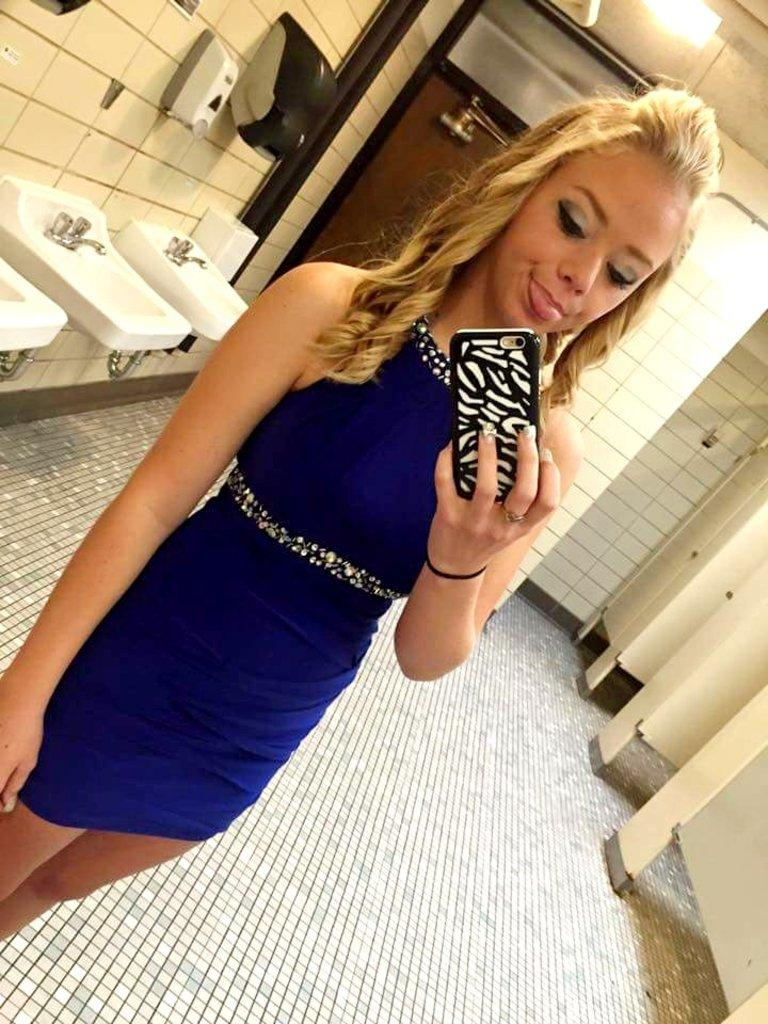What is the main subject of the image? There is a beautiful woman in the image. What is the woman doing in the image? The woman is taking a selfie. Where is the woman located in the image? The woman is in a washroom. What is the woman wearing in the image? The woman is wearing a blue color dress. What can be seen on the left side of the image? There are wash basins on the left side of the image. How many frogs are sitting on the cup in the image? There is no cup or frogs present in the image. 